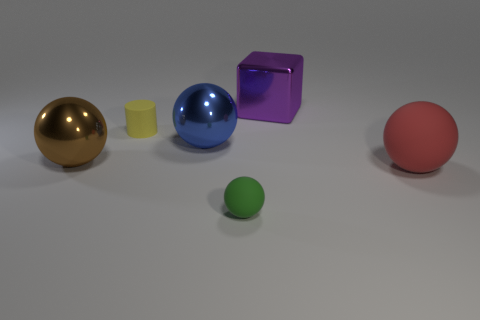Subtract all red spheres. How many spheres are left? 3 Add 4 red things. How many objects exist? 10 Subtract all blue spheres. How many spheres are left? 3 Subtract all brown balls. Subtract all blue blocks. How many balls are left? 3 Subtract all balls. How many objects are left? 2 Add 6 big metal spheres. How many big metal spheres exist? 8 Subtract 0 yellow spheres. How many objects are left? 6 Subtract all cyan shiny spheres. Subtract all tiny rubber cylinders. How many objects are left? 5 Add 2 big purple shiny blocks. How many big purple shiny blocks are left? 3 